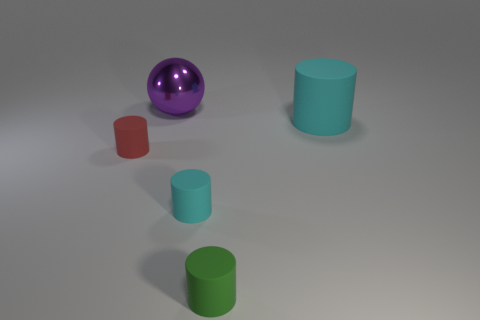Subtract all large cyan cylinders. How many cylinders are left? 3 Add 2 small yellow cylinders. How many objects exist? 7 Subtract all red cylinders. How many cylinders are left? 3 Subtract all spheres. How many objects are left? 4 Subtract 1 balls. How many balls are left? 0 Subtract all red matte spheres. Subtract all purple things. How many objects are left? 4 Add 1 large metallic balls. How many large metallic balls are left? 2 Add 2 green cylinders. How many green cylinders exist? 3 Subtract 0 gray blocks. How many objects are left? 5 Subtract all cyan spheres. Subtract all blue blocks. How many spheres are left? 1 